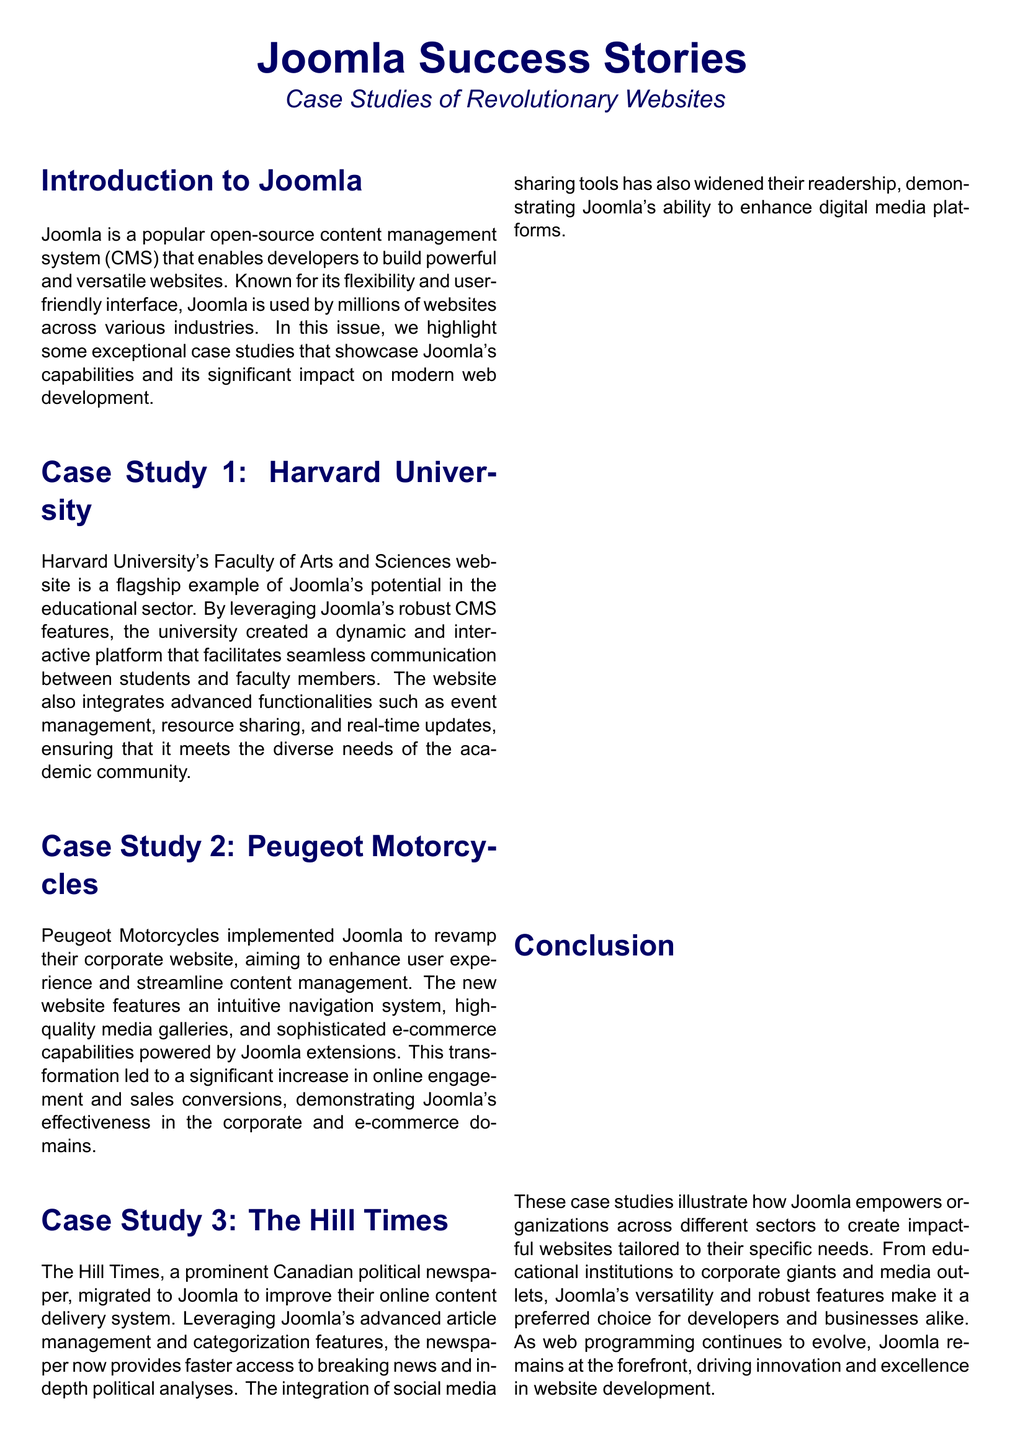What is the release date of Joomla? The release date of Joomla is mentioned in the Quick Facts section of the document.
Answer: 2005 What is the current version of Joomla? The current version is specified in the Quick Facts section.
Answer: Joomla 4 How many active websites use Joomla? The number of active websites is stated in the Quick Facts section.
Answer: Over 2 million Which university is highlighted in Case Study 1? The university featured in the first case study is mentioned in its title.
Answer: Harvard University What did Peugeot Motorcycles aim to enhance with Joomla? The aim to enhance is highlighted in their case study description.
Answer: User experience Which Canadian newspaper migrated to Joomla? The name of the newspaper is presented in Case Study 3.
Answer: The Hill Times What type of organizations are mentioned as using Joomla? This is discussed in the Conclusion section, summarizing the types of organizations.
Answer: Educational institutions, corporate giants, and media outlets What color is the title section of the document? The document states that the title section uses a specific color.
Answer: Dark blue 